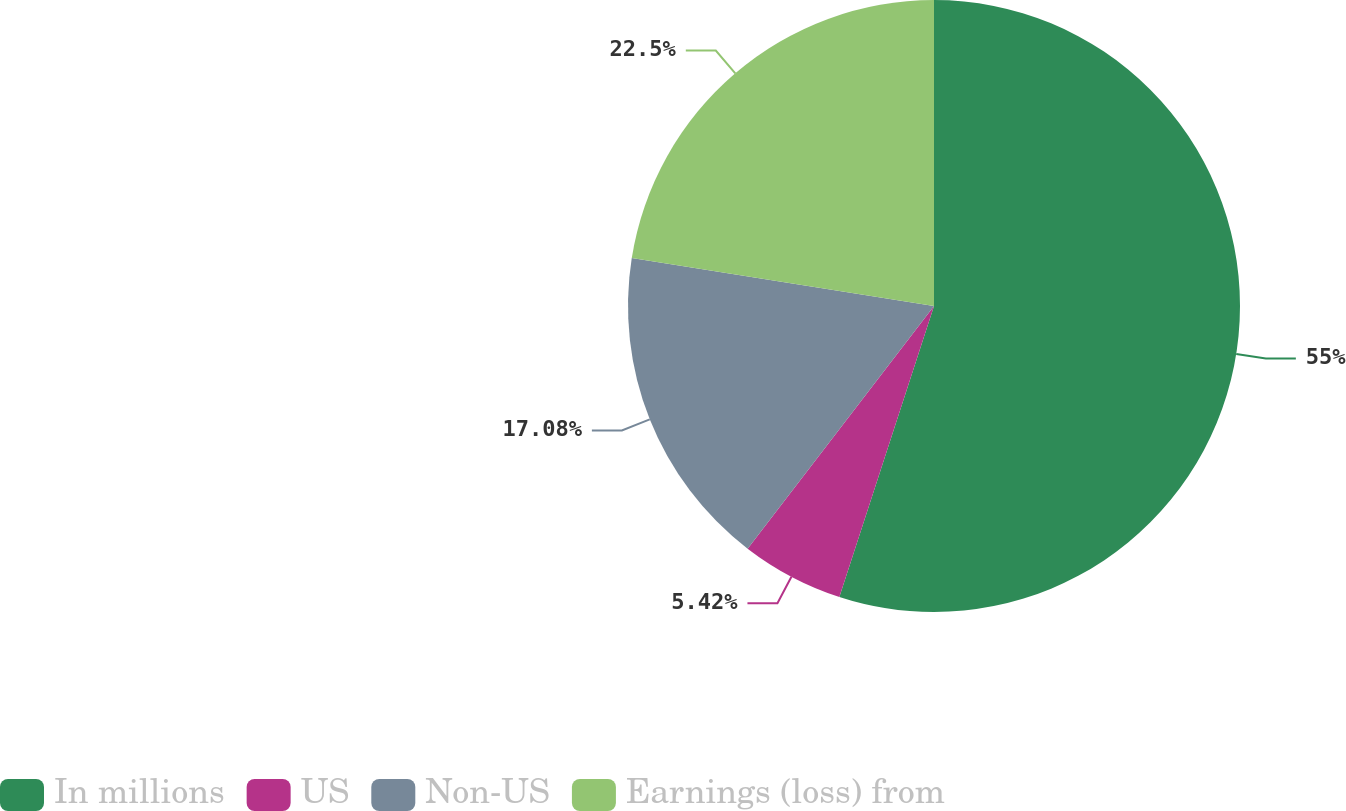Convert chart to OTSL. <chart><loc_0><loc_0><loc_500><loc_500><pie_chart><fcel>In millions<fcel>US<fcel>Non-US<fcel>Earnings (loss) from<nl><fcel>55.01%<fcel>5.42%<fcel>17.08%<fcel>22.5%<nl></chart> 